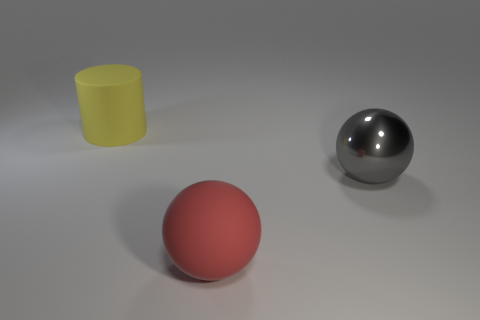Add 1 purple shiny things. How many objects exist? 4 Subtract all balls. How many objects are left? 1 Add 2 small green matte cylinders. How many small green matte cylinders exist? 2 Subtract 0 purple cylinders. How many objects are left? 3 Subtract all matte cylinders. Subtract all tiny purple metal objects. How many objects are left? 2 Add 3 matte cylinders. How many matte cylinders are left? 4 